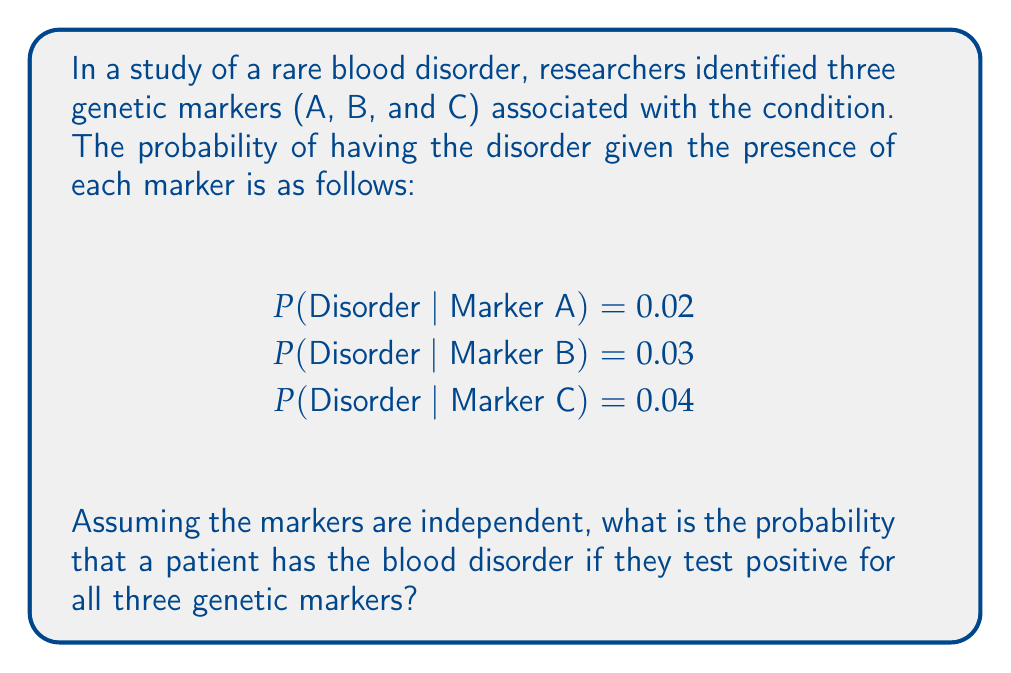Could you help me with this problem? To solve this problem, we'll use Bayes' theorem and the assumption of independence between markers. Let's break it down step-by-step:

1) We want to find P(Disorder | A ∩ B ∩ C), which is the probability of having the disorder given all three markers are present.

2) Using Bayes' theorem:

   $$P(Disorder | A ∩ B ∩ C) = \frac{P(A ∩ B ∩ C | Disorder) \cdot P(Disorder)}{P(A ∩ B ∩ C)}$$

3) Assuming independence, we can write:

   $$P(A ∩ B ∩ C | Disorder) = P(A | Disorder) \cdot P(B | Disorder) \cdot P(C | Disorder)$$

4) We don't have these probabilities directly, but we can use Bayes' theorem again:

   $$P(A | Disorder) = \frac{P(Disorder | A) \cdot P(A)}{P(Disorder)}$$

   Similarly for B and C.

5) Substituting these into our original equation:

   $$P(Disorder | A ∩ B ∩ C) = \frac{P(Disorder | A) \cdot P(Disorder | B) \cdot P(Disorder | C) \cdot P(A) \cdot P(B) \cdot P(C)}{P(Disorder)^2 \cdot P(A ∩ B ∩ C)}$$

6) The P(A), P(B), P(C), and P(Disorder) terms cancel out in the numerator and denominator:

   $$P(Disorder | A ∩ B ∩ C) = \frac{P(Disorder | A) \cdot P(Disorder | B) \cdot P(Disorder | C)}{P(A ∩ B ∩ C)}$$

7) We're given P(Disorder | A), P(Disorder | B), and P(Disorder | C). Substituting these values:

   $$P(Disorder | A ∩ B ∩ C) = \frac{0.02 \cdot 0.03 \cdot 0.04}{P(A ∩ B ∩ C)}$$

8) We don't know P(A ∩ B ∩ C), but it must be less than or equal to the smallest of P(A), P(B), and P(C). Therefore, P(Disorder | A ∩ B ∩ C) must be greater than or equal to 0.02 * 0.03 * 0.04 = 0.000024.

9) Calculate the final probability:

   $$P(Disorder | A ∩ B ∩ C) ≥ 0.000024 = 2.4 \times 10^{-5}$$

This is the lower bound of the probability. The actual probability could be higher depending on the true value of P(A ∩ B ∩ C).
Answer: $≥ 2.4 \times 10^{-5}$ 